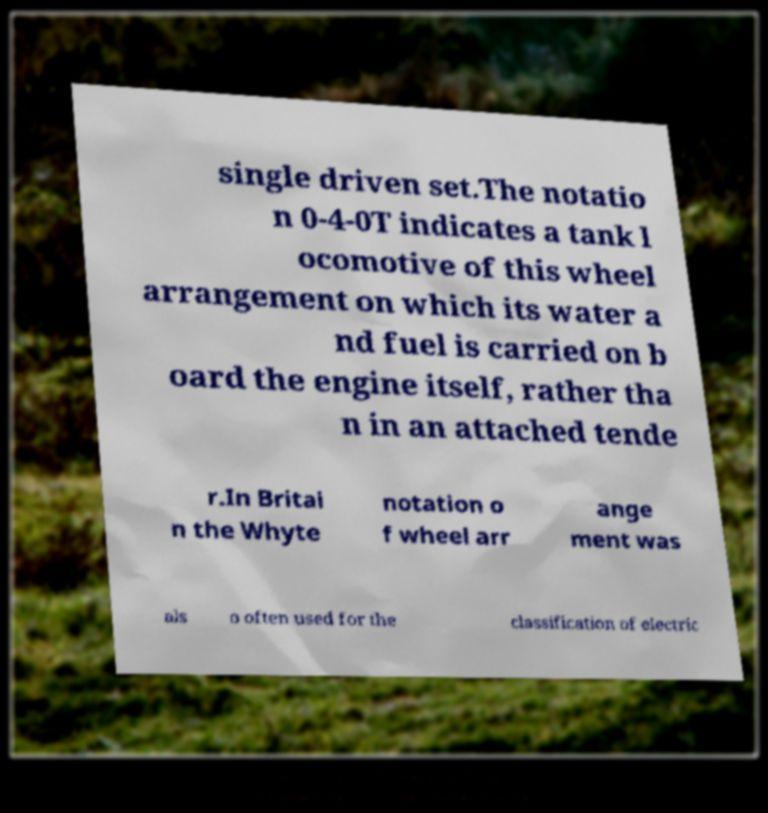I need the written content from this picture converted into text. Can you do that? single driven set.The notatio n 0-4-0T indicates a tank l ocomotive of this wheel arrangement on which its water a nd fuel is carried on b oard the engine itself, rather tha n in an attached tende r.In Britai n the Whyte notation o f wheel arr ange ment was als o often used for the classification of electric 